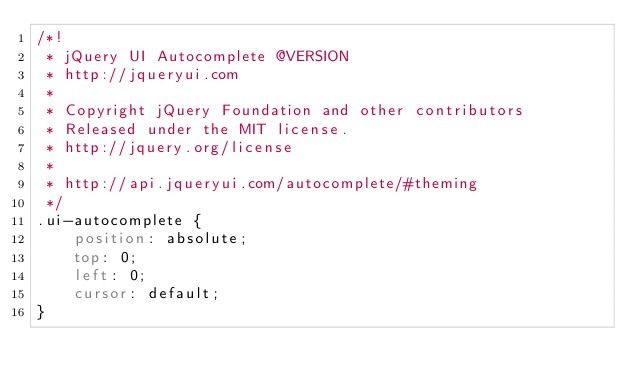<code> <loc_0><loc_0><loc_500><loc_500><_CSS_>/*!
 * jQuery UI Autocomplete @VERSION
 * http://jqueryui.com
 *
 * Copyright jQuery Foundation and other contributors
 * Released under the MIT license.
 * http://jquery.org/license
 *
 * http://api.jqueryui.com/autocomplete/#theming
 */
.ui-autocomplete {
	position: absolute;
	top: 0;
	left: 0;
	cursor: default;
}
</code> 